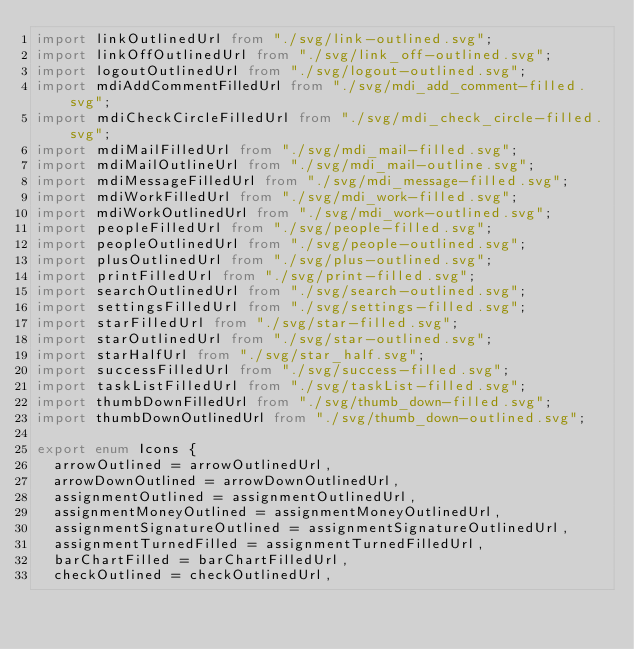<code> <loc_0><loc_0><loc_500><loc_500><_TypeScript_>import linkOutlinedUrl from "./svg/link-outlined.svg";
import linkOffOutlinedUrl from "./svg/link_off-outlined.svg";
import logoutOutlinedUrl from "./svg/logout-outlined.svg";
import mdiAddCommentFilledUrl from "./svg/mdi_add_comment-filled.svg";
import mdiCheckCircleFilledUrl from "./svg/mdi_check_circle-filled.svg";
import mdiMailFilledUrl from "./svg/mdi_mail-filled.svg";
import mdiMailOutlineUrl from "./svg/mdi_mail-outline.svg";
import mdiMessageFilledUrl from "./svg/mdi_message-filled.svg";
import mdiWorkFilledUrl from "./svg/mdi_work-filled.svg";
import mdiWorkOutlinedUrl from "./svg/mdi_work-outlined.svg";
import peopleFilledUrl from "./svg/people-filled.svg";
import peopleOutlinedUrl from "./svg/people-outlined.svg";
import plusOutlinedUrl from "./svg/plus-outlined.svg";
import printFilledUrl from "./svg/print-filled.svg";
import searchOutlinedUrl from "./svg/search-outlined.svg";
import settingsFilledUrl from "./svg/settings-filled.svg";
import starFilledUrl from "./svg/star-filled.svg";
import starOutlinedUrl from "./svg/star-outlined.svg";
import starHalfUrl from "./svg/star_half.svg";
import successFilledUrl from "./svg/success-filled.svg";
import taskListFilledUrl from "./svg/taskList-filled.svg";
import thumbDownFilledUrl from "./svg/thumb_down-filled.svg";
import thumbDownOutlinedUrl from "./svg/thumb_down-outlined.svg";

export enum Icons {
  arrowOutlined = arrowOutlinedUrl,
  arrowDownOutlined = arrowDownOutlinedUrl,
  assignmentOutlined = assignmentOutlinedUrl,
  assignmentMoneyOutlined = assignmentMoneyOutlinedUrl,
  assignmentSignatureOutlined = assignmentSignatureOutlinedUrl,
  assignmentTurnedFilled = assignmentTurnedFilledUrl,
  barChartFilled = barChartFilledUrl,
  checkOutlined = checkOutlinedUrl,</code> 